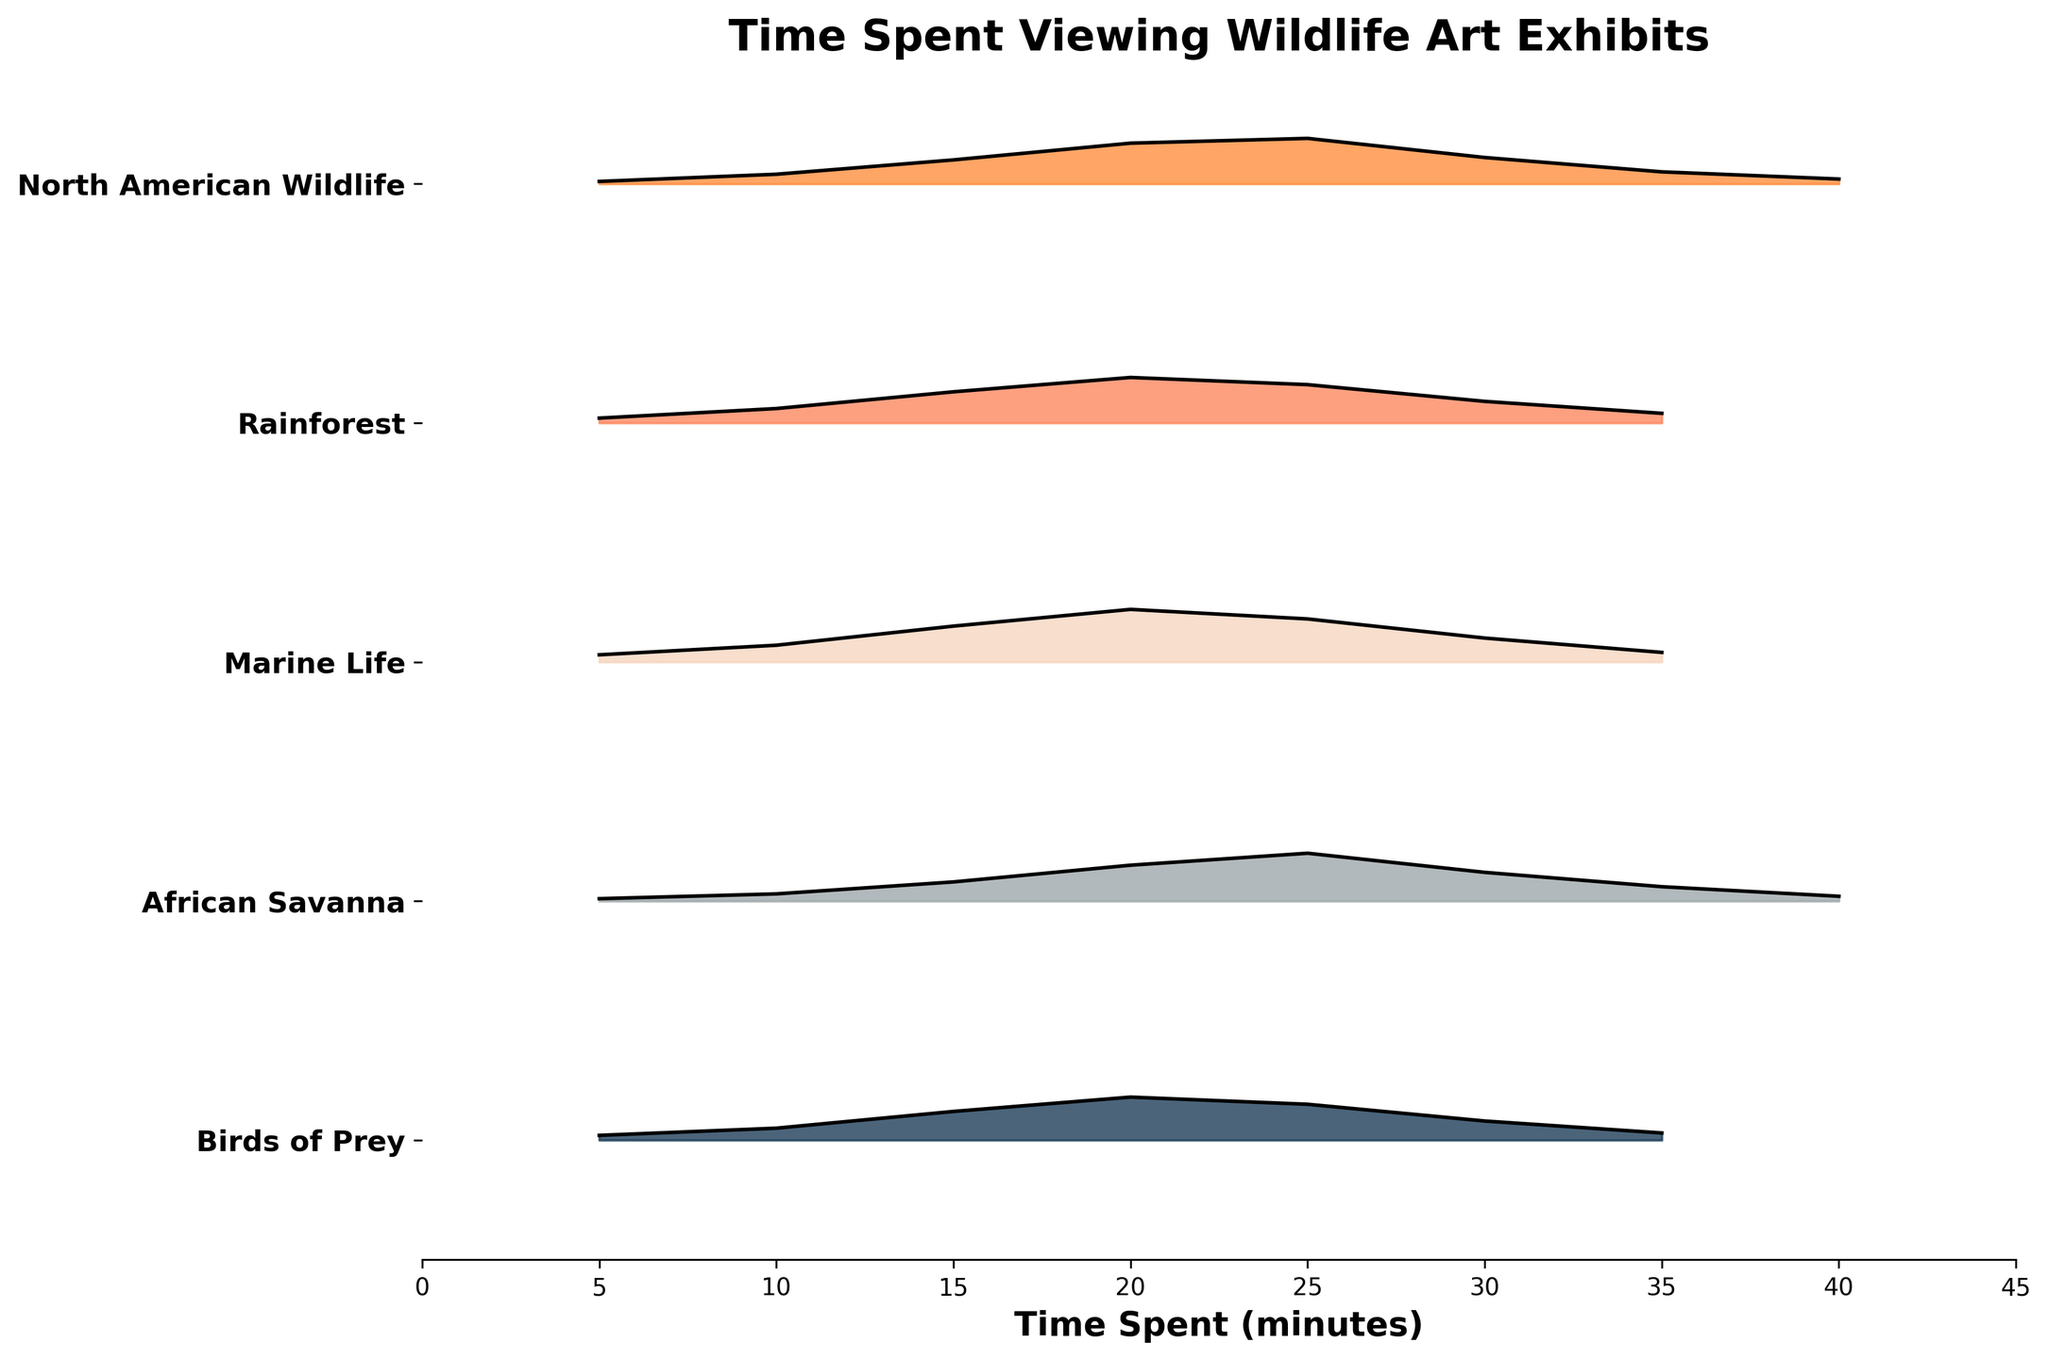How many exhibit themes are displayed in the plot? To determine the number of exhibit themes, look at the distinct labels on the y-axis. The themes listed from top to bottom are "Birds of Prey", "African Savanna", "Marine Life", "Rainforest", and "North American Wildlife".
Answer: 5 What is the title of the plot? To find the plot's title, look at the text prominently displayed at the top of the plot. The title is "Time Spent Viewing Wildlife Art Exhibits".
Answer: Time Spent Viewing Wildlife Art Exhibits Which exhibit theme appears to have the highest peak density? To determine which exhibit theme has the highest peak density, visually inspect the plot and compare the peak heights of the density lines for each theme. The theme with the highest peak is "Marine Life".
Answer: Marine Life What is the approximate time visitors spent at the peak density for "Birds of Prey"? To find the peak density for "Birds of Prey," locate the highest point of its corresponding area on the plot. The peak density occurs around 20 minutes.
Answer: 20 minutes Compare the peak density times for "African Savanna" and "Rainforest." Which one is higher and by how much? To compare, locate the highest density points for both themes. The peak density for "African Savanna" is around 25 minutes, and for "Rainforest," it is around 20 minutes. "African Savanna" has a higher peak density, and the difference is 5 minutes.
Answer: African Savanna by 5 minutes Which exhibit theme has both the earliest and latest recorded times of visitor engagement? To identify both the earliest and latest times, look at the range of the x-axis values for each exhibit theme. "North American Wildlife" has recorded times from 5 minutes to 40 minutes, covering the widest range.
Answer: North American Wildlife What is the total range of time visitors spent viewing the "African Savanna" exhibit? The total range is the difference between the maximum and minimum times recorded for "African Savanna". It spans from 5 minutes to 40 minutes. Therefore, the range is 35 minutes.
Answer: 35 minutes Rank the exhibit themes from most to least time spent at the peak density. To rank the themes, observe the heights of the density peaks for each exhibit theme. "Marine Life" has the highest peak, followed by "Rainforest", "African Savanna", "Birds of Prey", and "North American Wildlife".
Answer: Marine Life, Rainforest, African Savanna, Birds of Prey, North American Wildlife What is the density value for "Rainforest" at the 20-minute mark? To find this, look at the density plot for "Rainforest" at the 20-minute mark. The density value at this point is approximately 0.19.
Answer: 0.19 Which exhibit theme has the least visitor density at the 5-minute mark? To find the exhibit with the lowest density at 5 minutes, compare the density values at the 5-minute mark for each theme. "North American Wildlife" has the lowest density at this point, with a value of 0.01.
Answer: North American Wildlife 